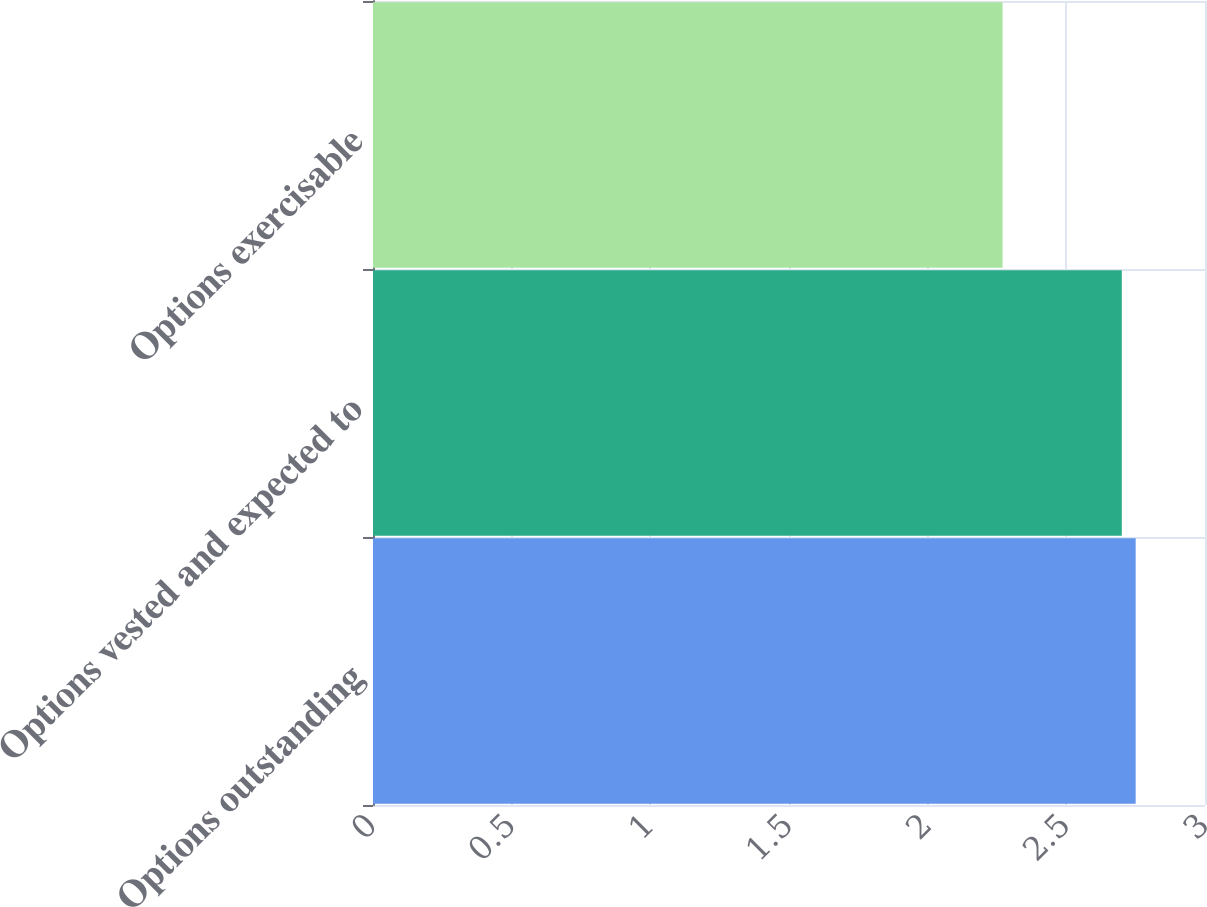Convert chart to OTSL. <chart><loc_0><loc_0><loc_500><loc_500><bar_chart><fcel>Options outstanding<fcel>Options vested and expected to<fcel>Options exercisable<nl><fcel>2.75<fcel>2.7<fcel>2.27<nl></chart> 